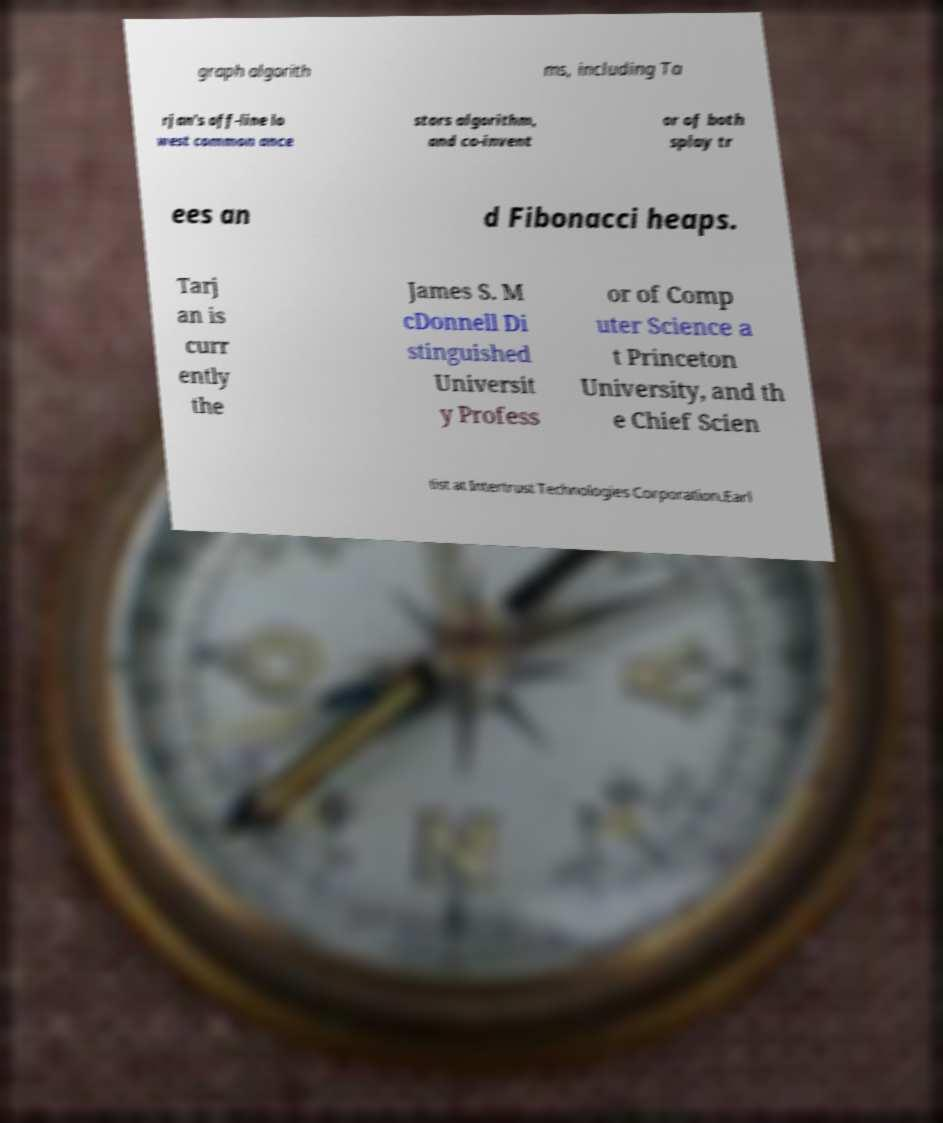Can you accurately transcribe the text from the provided image for me? graph algorith ms, including Ta rjan's off-line lo west common ance stors algorithm, and co-invent or of both splay tr ees an d Fibonacci heaps. Tarj an is curr ently the James S. M cDonnell Di stinguished Universit y Profess or of Comp uter Science a t Princeton University, and th e Chief Scien tist at Intertrust Technologies Corporation.Earl 